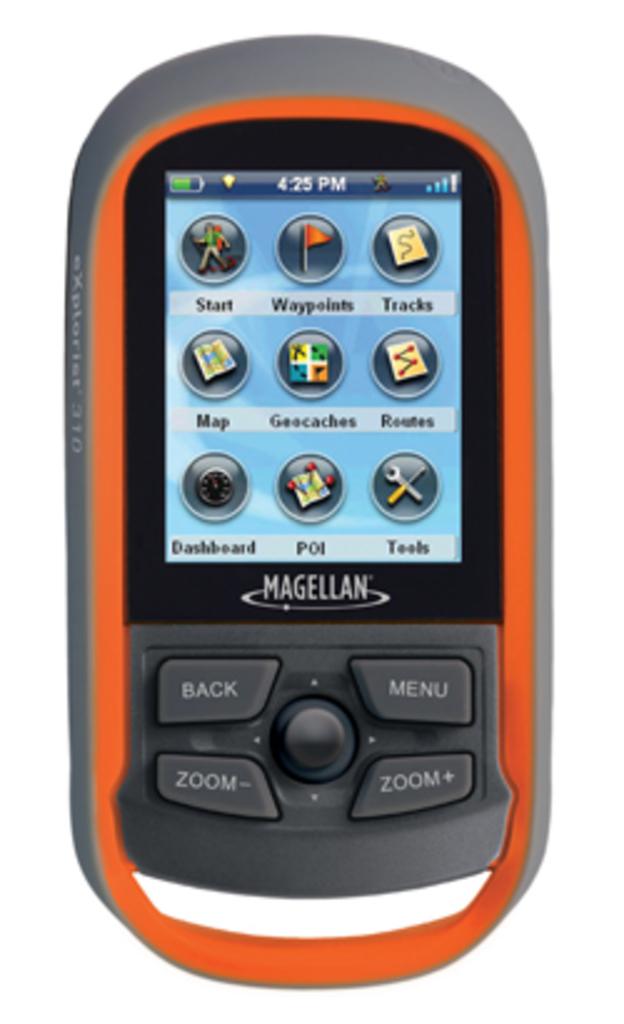What does the the middle widget say?
Offer a very short reply. Geocaches. What brand is this device?
Your answer should be compact. Magellan. 